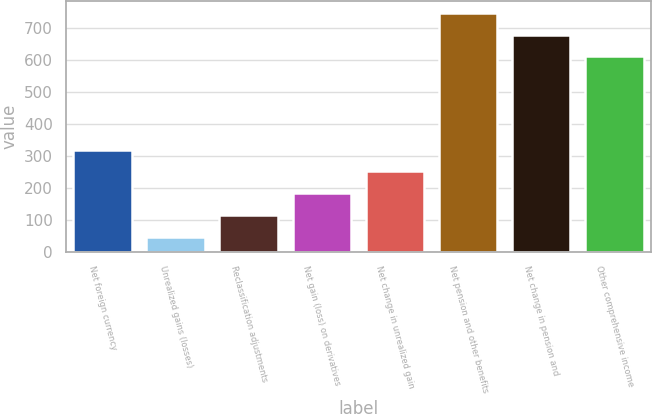<chart> <loc_0><loc_0><loc_500><loc_500><bar_chart><fcel>Net foreign currency<fcel>Unrealized gains (losses)<fcel>Reclassification adjustments<fcel>Net gain (loss) on derivatives<fcel>Net change in unrealized gain<fcel>Net pension and other benefits<fcel>Net change in pension and<fcel>Other comprehensive income<nl><fcel>319.6<fcel>48<fcel>115.9<fcel>183.8<fcel>251.7<fcel>746.8<fcel>678.9<fcel>611<nl></chart> 